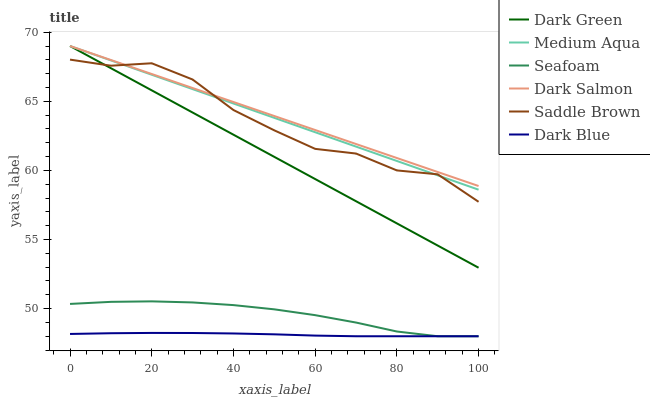Does Dark Blue have the minimum area under the curve?
Answer yes or no. Yes. Does Dark Salmon have the maximum area under the curve?
Answer yes or no. Yes. Does Seafoam have the minimum area under the curve?
Answer yes or no. No. Does Seafoam have the maximum area under the curve?
Answer yes or no. No. Is Medium Aqua the smoothest?
Answer yes or no. Yes. Is Saddle Brown the roughest?
Answer yes or no. Yes. Is Seafoam the smoothest?
Answer yes or no. No. Is Seafoam the roughest?
Answer yes or no. No. Does Seafoam have the lowest value?
Answer yes or no. Yes. Does Medium Aqua have the lowest value?
Answer yes or no. No. Does Dark Green have the highest value?
Answer yes or no. Yes. Does Seafoam have the highest value?
Answer yes or no. No. Is Dark Blue less than Medium Aqua?
Answer yes or no. Yes. Is Saddle Brown greater than Seafoam?
Answer yes or no. Yes. Does Dark Salmon intersect Dark Green?
Answer yes or no. Yes. Is Dark Salmon less than Dark Green?
Answer yes or no. No. Is Dark Salmon greater than Dark Green?
Answer yes or no. No. Does Dark Blue intersect Medium Aqua?
Answer yes or no. No. 